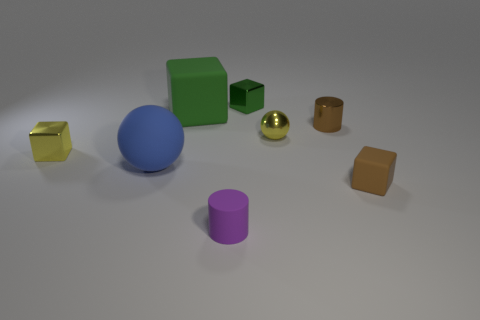What number of things are both in front of the green metal block and behind the matte cylinder?
Your answer should be compact. 6. Are the blue thing and the small cube that is on the right side of the small brown cylinder made of the same material?
Your answer should be compact. Yes. What number of cyan things are big blocks or small matte objects?
Give a very brief answer. 0. Is there a cyan metallic object of the same size as the matte cylinder?
Provide a succinct answer. No. What material is the brown object that is on the left side of the brown rubber thing to the right of the tiny yellow ball in front of the large green matte object?
Make the answer very short. Metal. Are there the same number of brown rubber things that are in front of the tiny purple matte thing and large things?
Keep it short and to the point. No. Is the material of the yellow cube that is to the left of the large blue rubber ball the same as the small cube that is in front of the rubber sphere?
Provide a short and direct response. No. How many objects are either tiny green blocks or green cubes that are right of the small purple cylinder?
Your answer should be compact. 1. Is there a green metallic object that has the same shape as the tiny brown shiny object?
Keep it short and to the point. No. What size is the metallic thing that is left of the green block that is behind the rubber cube that is left of the brown cube?
Your answer should be very brief. Small. 